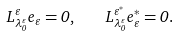<formula> <loc_0><loc_0><loc_500><loc_500>L ^ { \varepsilon } _ { \lambda ^ { \varepsilon } _ { 0 } } e _ { \varepsilon } = 0 , \quad L ^ { \varepsilon ^ { * } } _ { \lambda ^ { \varepsilon } _ { 0 } } e ^ { * } _ { \varepsilon } = 0 .</formula> 